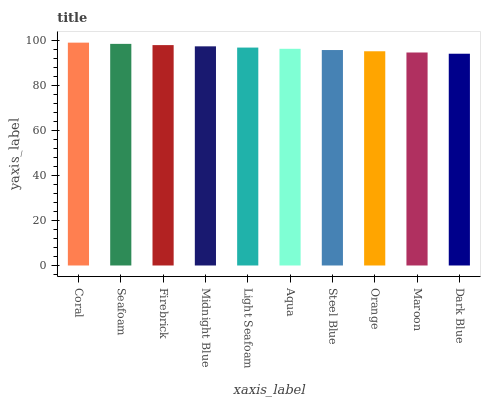Is Dark Blue the minimum?
Answer yes or no. Yes. Is Coral the maximum?
Answer yes or no. Yes. Is Seafoam the minimum?
Answer yes or no. No. Is Seafoam the maximum?
Answer yes or no. No. Is Coral greater than Seafoam?
Answer yes or no. Yes. Is Seafoam less than Coral?
Answer yes or no. Yes. Is Seafoam greater than Coral?
Answer yes or no. No. Is Coral less than Seafoam?
Answer yes or no. No. Is Light Seafoam the high median?
Answer yes or no. Yes. Is Aqua the low median?
Answer yes or no. Yes. Is Orange the high median?
Answer yes or no. No. Is Steel Blue the low median?
Answer yes or no. No. 